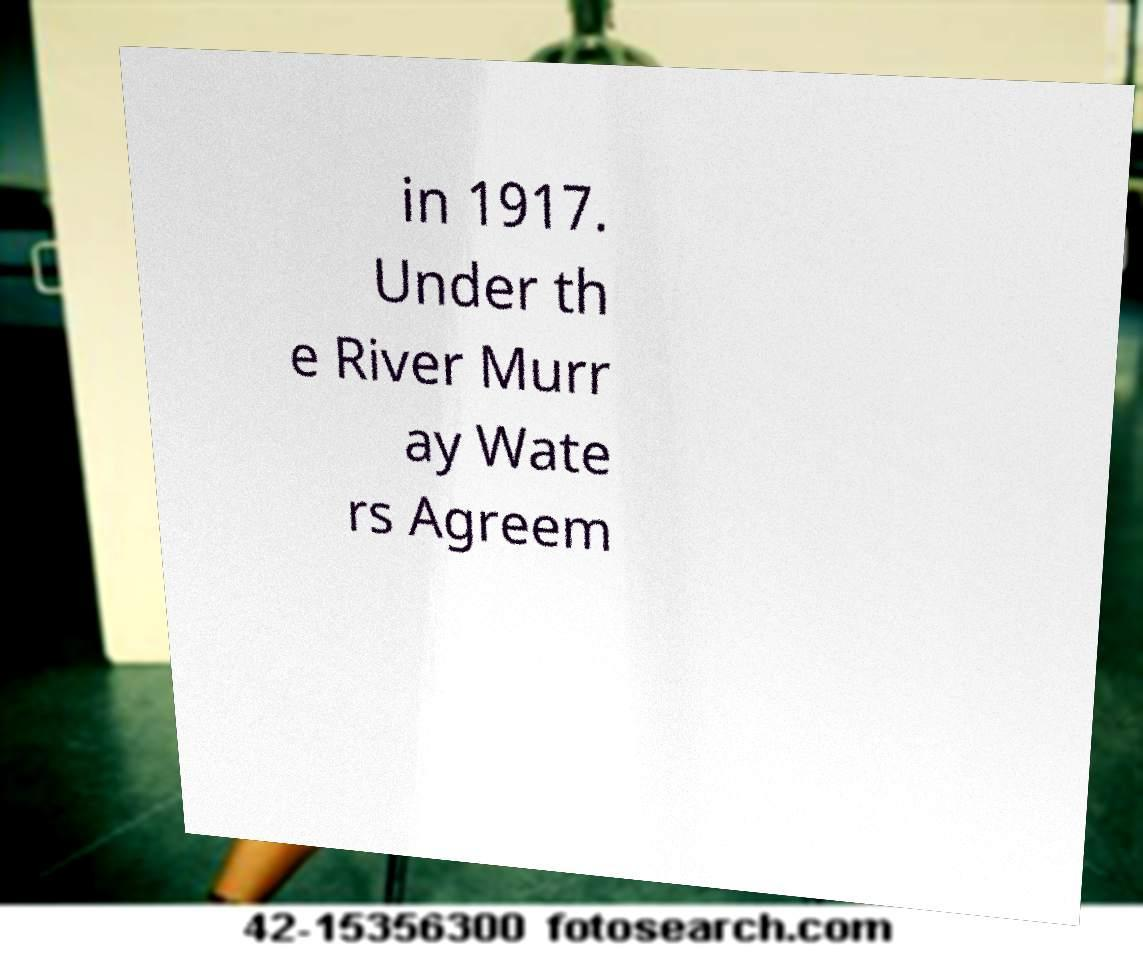What messages or text are displayed in this image? I need them in a readable, typed format. in 1917. Under th e River Murr ay Wate rs Agreem 